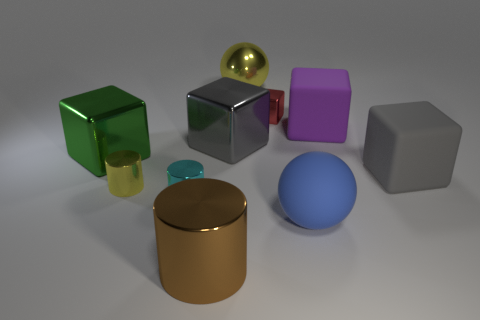Subtract all small red cubes. How many cubes are left? 4 Subtract all yellow cylinders. How many cylinders are left? 2 Subtract 3 cubes. How many cubes are left? 2 Add 4 small metal cylinders. How many small metal cylinders are left? 6 Add 10 small cyan matte cylinders. How many small cyan matte cylinders exist? 10 Subtract 1 yellow spheres. How many objects are left? 9 Subtract all spheres. How many objects are left? 8 Subtract all brown blocks. Subtract all red cylinders. How many blocks are left? 5 Subtract all brown balls. How many green cylinders are left? 0 Subtract all small metal cylinders. Subtract all tiny objects. How many objects are left? 5 